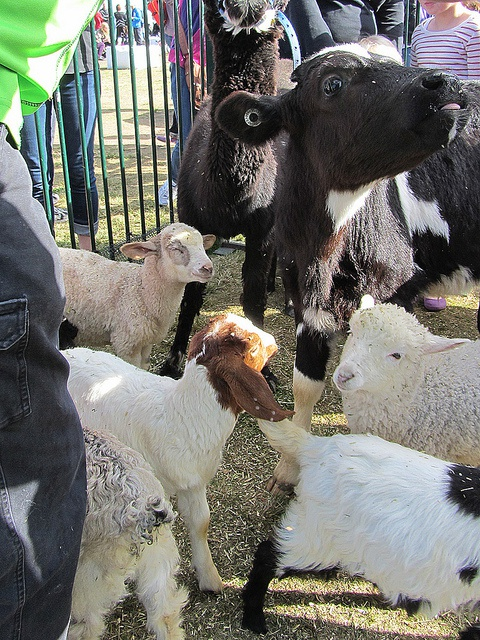Describe the objects in this image and their specific colors. I can see cow in lightgreen, black, gray, darkgray, and lightgray tones, people in lightgreen, black, gray, and white tones, sheep in lightgreen, darkgray, lightgray, and black tones, sheep in lightgreen, darkgray, lightgray, maroon, and gray tones, and sheep in lightgreen, darkgray, lightgray, and gray tones in this image. 